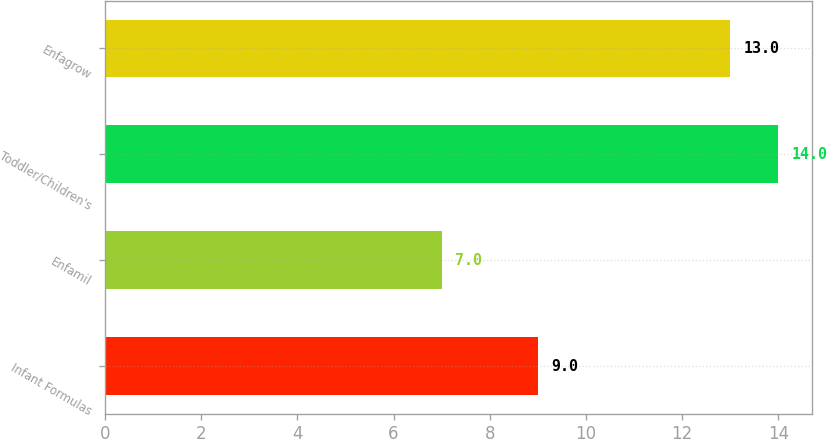Convert chart to OTSL. <chart><loc_0><loc_0><loc_500><loc_500><bar_chart><fcel>Infant Formulas<fcel>Enfamil<fcel>Toddler/Children's<fcel>Enfagrow<nl><fcel>9<fcel>7<fcel>14<fcel>13<nl></chart> 